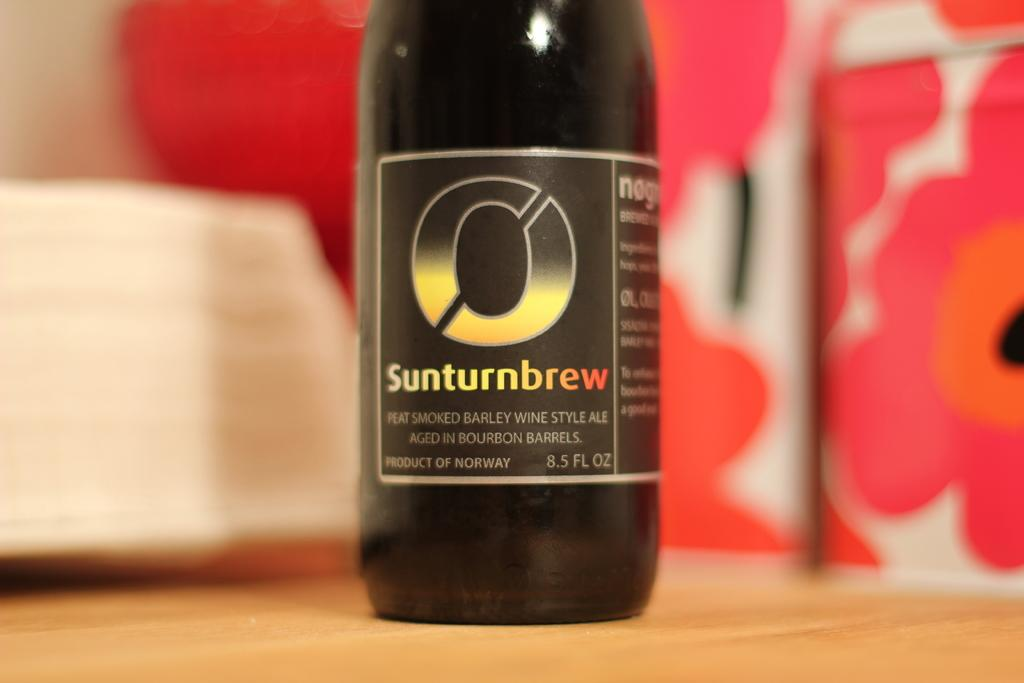<image>
Relay a brief, clear account of the picture shown. A Sunturnbrew bottle of peat smoked barley wine ale sits on a wood counter. 